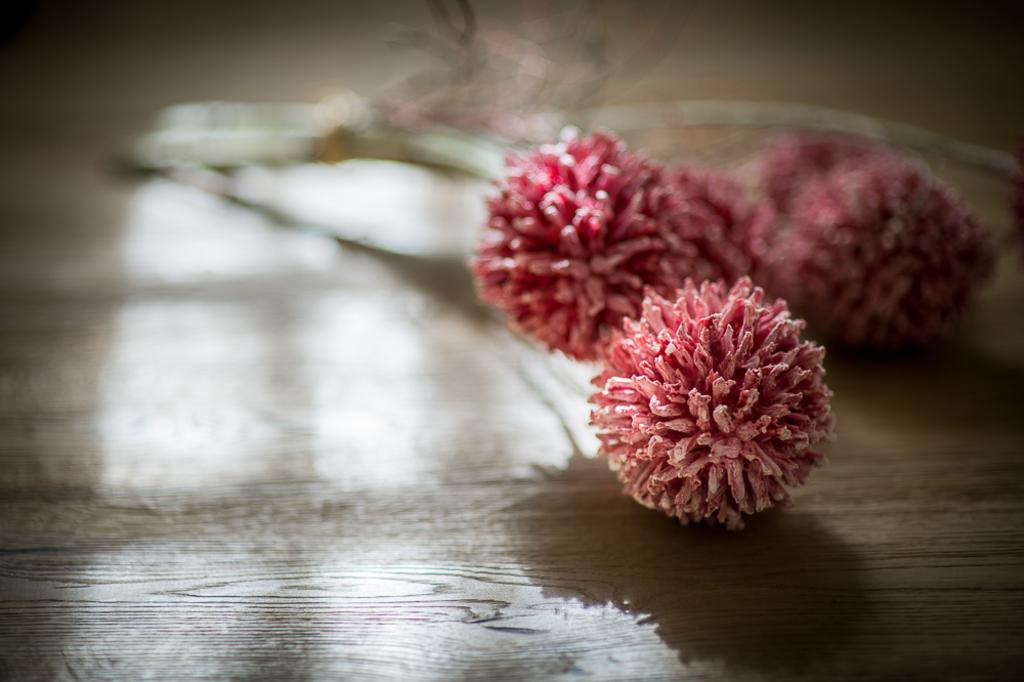What is placed on the floor in the image? There are flowers on the floor in the image. What direction is the hammer facing in the image? There is no hammer present in the image; it only features flowers on the floor. 